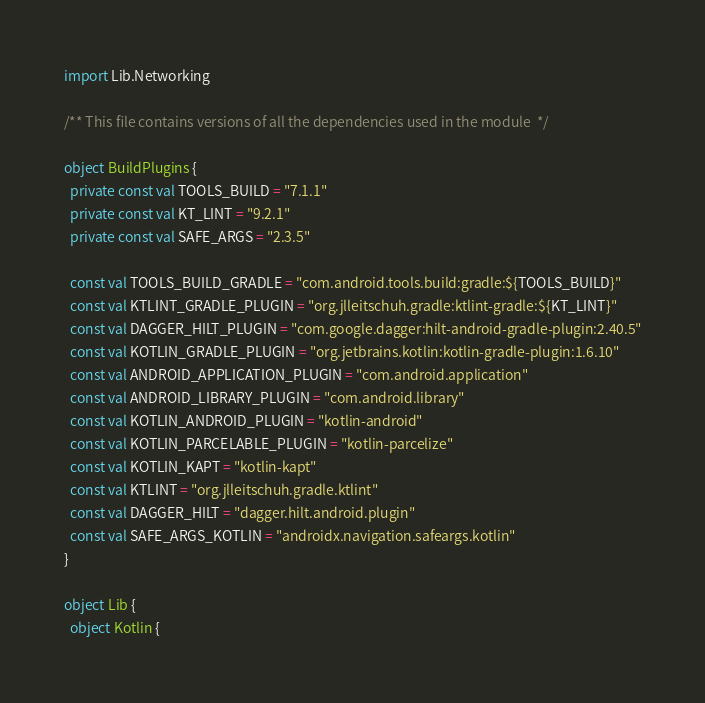<code> <loc_0><loc_0><loc_500><loc_500><_Kotlin_>import Lib.Networking

/** This file contains versions of all the dependencies used in the module  */

object BuildPlugins {
  private const val TOOLS_BUILD = "7.1.1"
  private const val KT_LINT = "9.2.1"
  private const val SAFE_ARGS = "2.3.5"

  const val TOOLS_BUILD_GRADLE = "com.android.tools.build:gradle:${TOOLS_BUILD}"
  const val KTLINT_GRADLE_PLUGIN = "org.jlleitschuh.gradle:ktlint-gradle:${KT_LINT}"
  const val DAGGER_HILT_PLUGIN = "com.google.dagger:hilt-android-gradle-plugin:2.40.5"
  const val KOTLIN_GRADLE_PLUGIN = "org.jetbrains.kotlin:kotlin-gradle-plugin:1.6.10"
  const val ANDROID_APPLICATION_PLUGIN = "com.android.application"
  const val ANDROID_LIBRARY_PLUGIN = "com.android.library"
  const val KOTLIN_ANDROID_PLUGIN = "kotlin-android"
  const val KOTLIN_PARCELABLE_PLUGIN = "kotlin-parcelize"
  const val KOTLIN_KAPT = "kotlin-kapt"
  const val KTLINT = "org.jlleitschuh.gradle.ktlint"
  const val DAGGER_HILT = "dagger.hilt.android.plugin"
  const val SAFE_ARGS_KOTLIN = "androidx.navigation.safeargs.kotlin"
}

object Lib {
  object Kotlin {</code> 